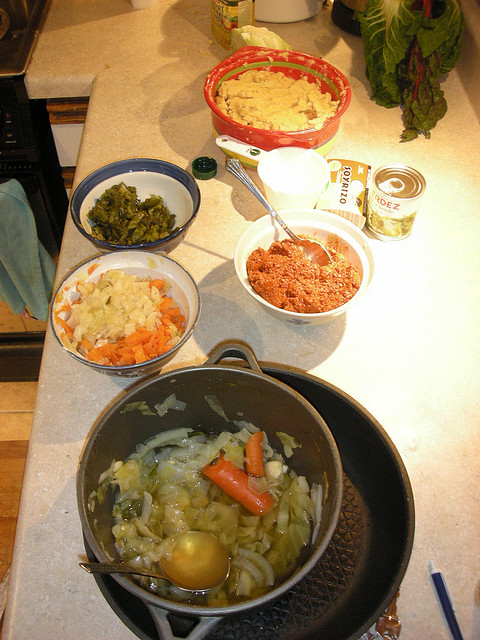What dishes are being prepared with these ingredients? It looks like someone might be preparing a hearty meal, possibly involving a type of stew or soup given the vegetables and broth seen in the main pot. The ground meat could be used for meatballs or as part of a filling in a pie or casserole, which might also include the vegetables. There's also a possibility of a side dish involving greens. 